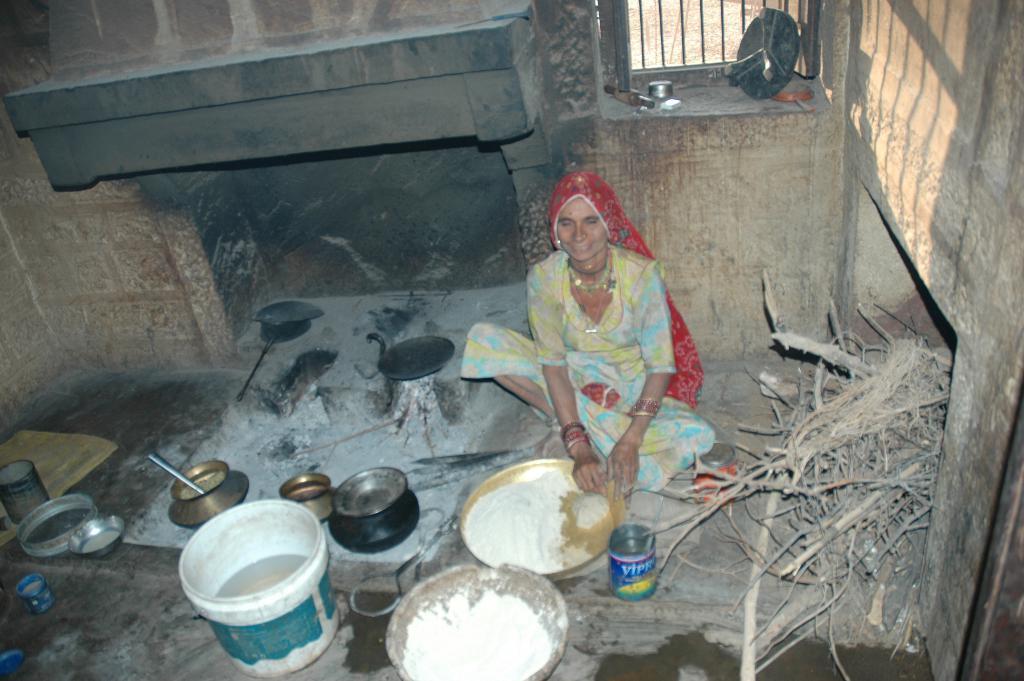Could you give a brief overview of what you see in this image? In the image there is a woman sitting on the floor. In front of her there is a plate with flour in it. And also there is a vessel with flour in it. On the floor there are few vessels and also there is a bucket with water in it. There is a wood burning stove with vessels on it. On the right side of the image there is a wall and also there are wooden sticks on the floor. In the background there is a wall and also there is a window with a few items. 